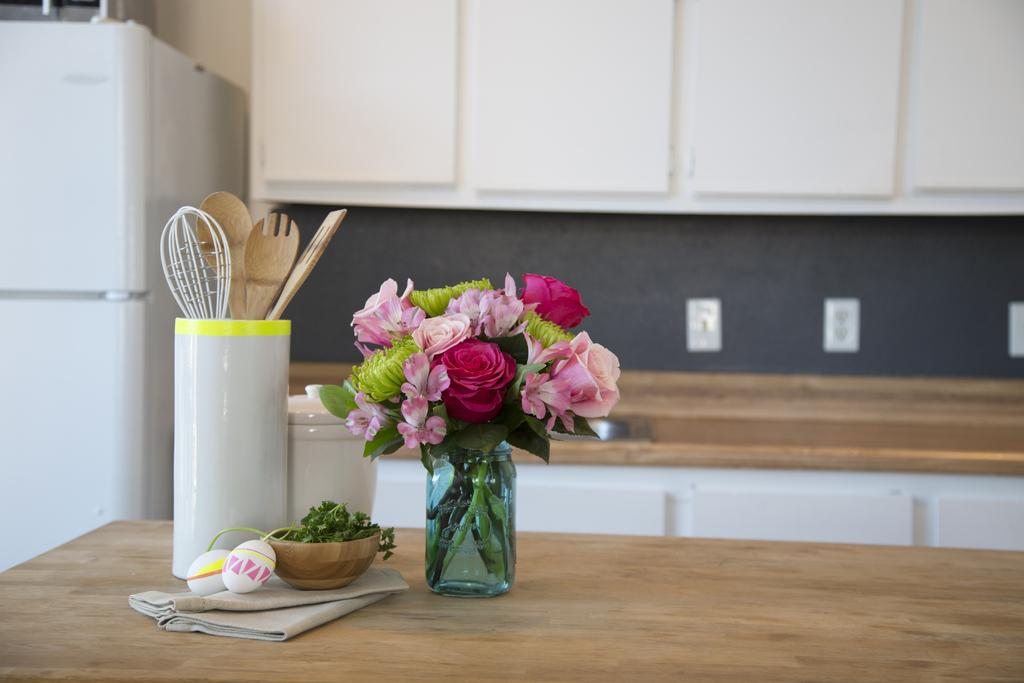What is contained in the glass jar in the image? There are flowers in a glass jar in the image. What can be found on the table in the image? There are utensils on the table in the image. Where is the refrigerator located in the image? The refrigerator is on the left side of the image. What color are the cupboards in the image? The cupboards in the image are white. Is there a throne in the image? No, there is no throne present in the image. What type of care is being provided to the flowers in the image? The image does not show any care being provided to the flowers; it only shows them in a glass jar. 